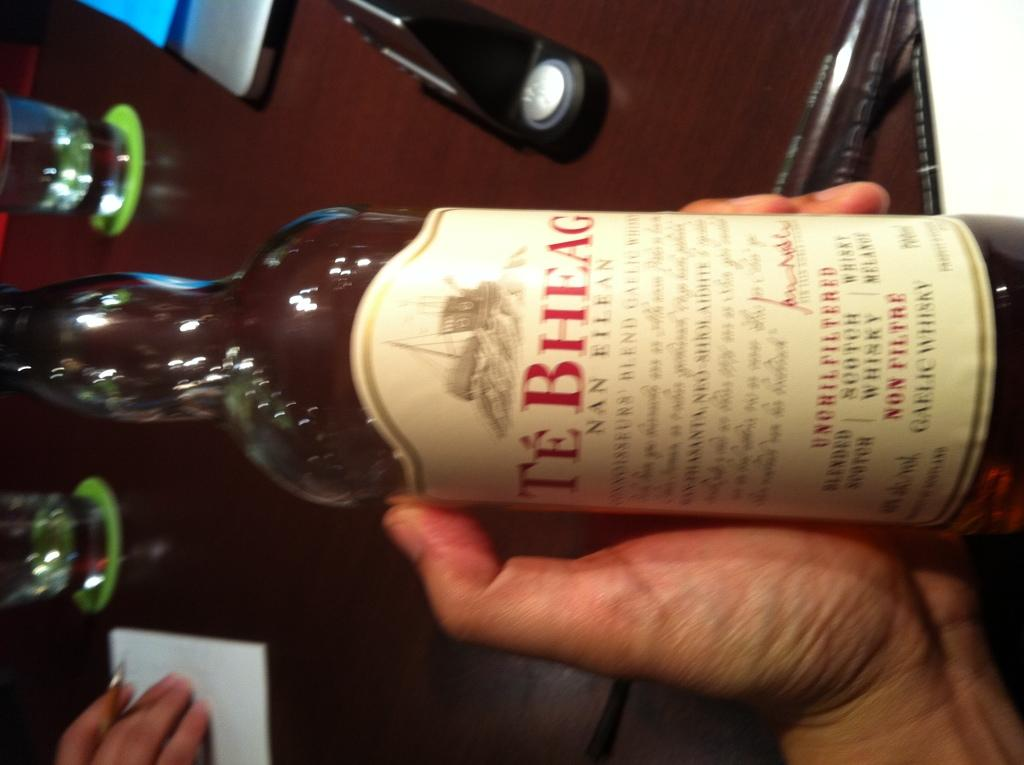<image>
Share a concise interpretation of the image provided. a close up of Te BHeag in someone's hand 